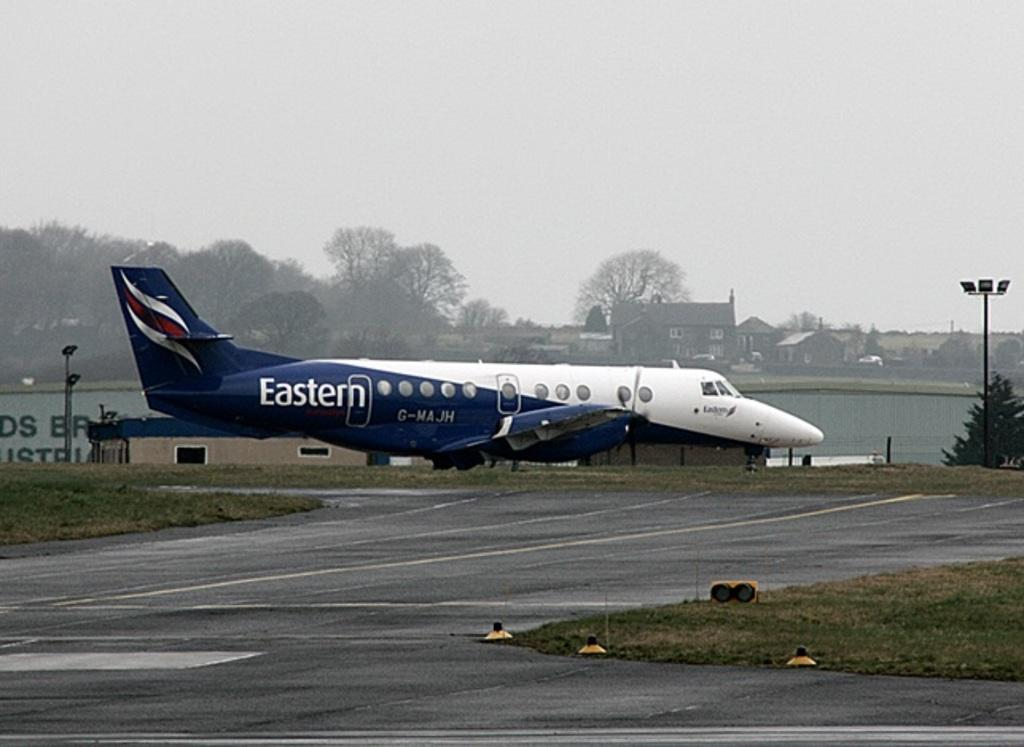<image>
Offer a succinct explanation of the picture presented. An Eastern plane sits on the airport runway. 